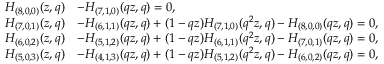Convert formula to latex. <formula><loc_0><loc_0><loc_500><loc_500>\begin{array} { r l } { H _ { ( 8 , 0 , 0 ) } ( z , q ) } & { - H _ { ( 7 , 1 , 0 ) } ( q z , q ) = 0 , } \\ { H _ { ( 7 , 0 , 1 ) } ( z , q ) } & { - H _ { ( 6 , 1 , 1 ) } ( q z , q ) + ( 1 - q z ) H _ { ( 7 , 1 , 0 ) } ( q ^ { 2 } z , q ) - H _ { ( 8 , 0 , 0 ) } ( q z , q ) = 0 , } \\ { H _ { ( 6 , 0 , 2 ) } ( z , q ) } & { - H _ { ( 5 , 1 , 2 ) } ( q z , q ) + ( 1 - q z ) H _ { ( 6 , 1 , 1 ) } ( q ^ { 2 } z , q ) - H _ { ( 7 , 0 , 1 ) } ( q z , q ) = 0 , } \\ { H _ { ( 5 , 0 , 3 ) } ( z , q ) } & { - H _ { ( 4 , 1 , 3 ) } ( q z , q ) + ( 1 - q z ) H _ { ( 5 , 1 , 2 ) } ( q ^ { 2 } z , q ) - H _ { ( 6 , 0 , 2 ) } ( q z , q ) = 0 , } \end{array}</formula> 